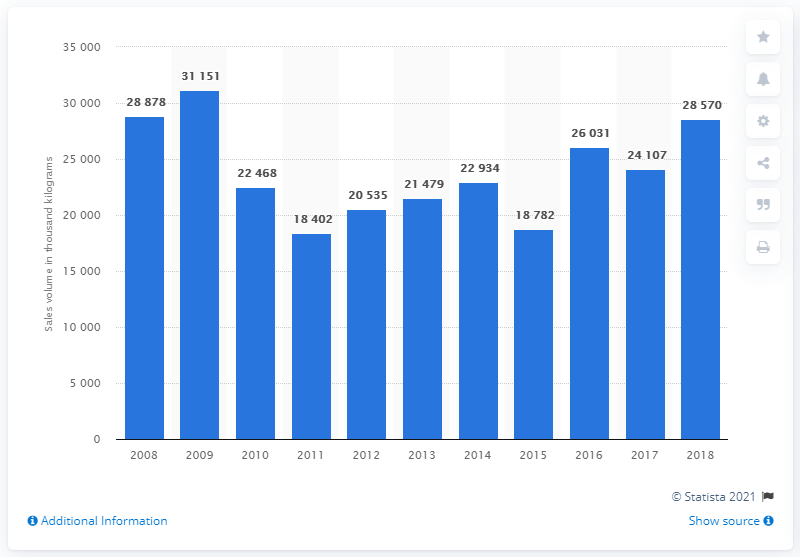What happened to the sales figures after 2009? After reaching the peak in 2009, the sales volume showed a declining pattern initially, reaching a low in 2011 at 18,402 thousand kilograms. Afterward, it experienced some fluctuation and mild recoveries, but didn't reach the heights of 2009 again by 2018. 